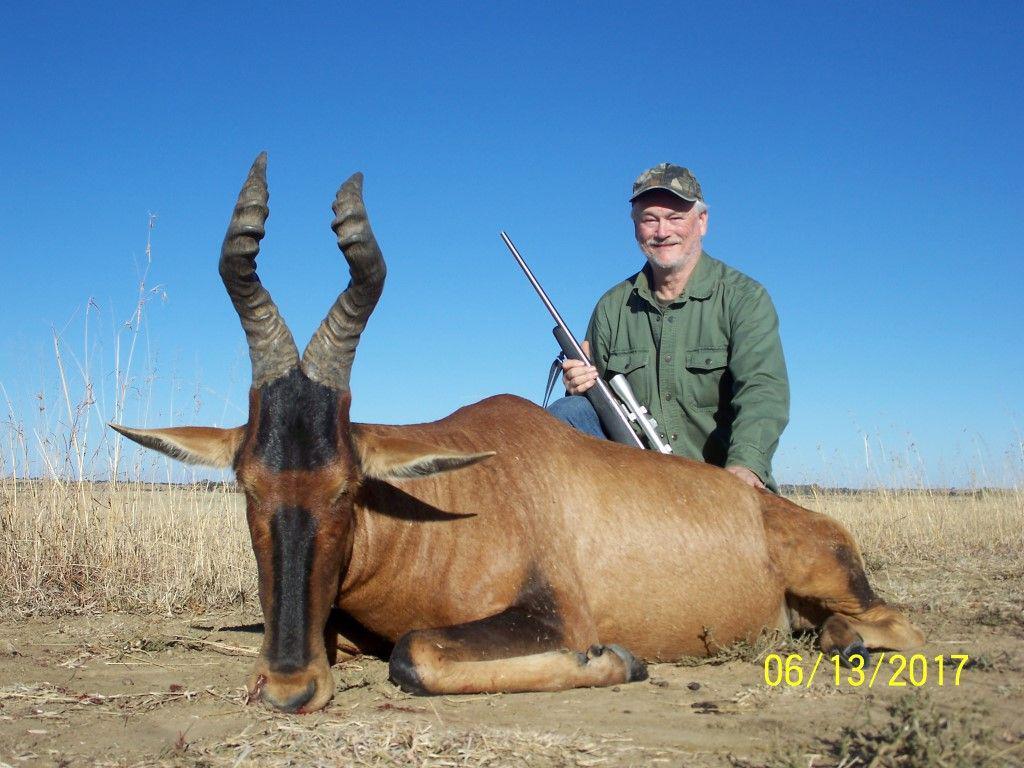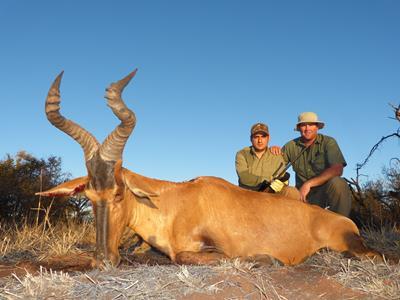The first image is the image on the left, the second image is the image on the right. Examine the images to the left and right. Is the description "There are exactly two men." accurate? Answer yes or no. No. 